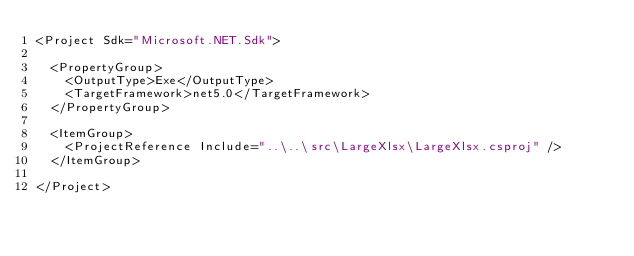<code> <loc_0><loc_0><loc_500><loc_500><_XML_><Project Sdk="Microsoft.NET.Sdk">

  <PropertyGroup>
    <OutputType>Exe</OutputType>
    <TargetFramework>net5.0</TargetFramework>
  </PropertyGroup>

  <ItemGroup>
    <ProjectReference Include="..\..\src\LargeXlsx\LargeXlsx.csproj" />
  </ItemGroup>

</Project>
</code> 